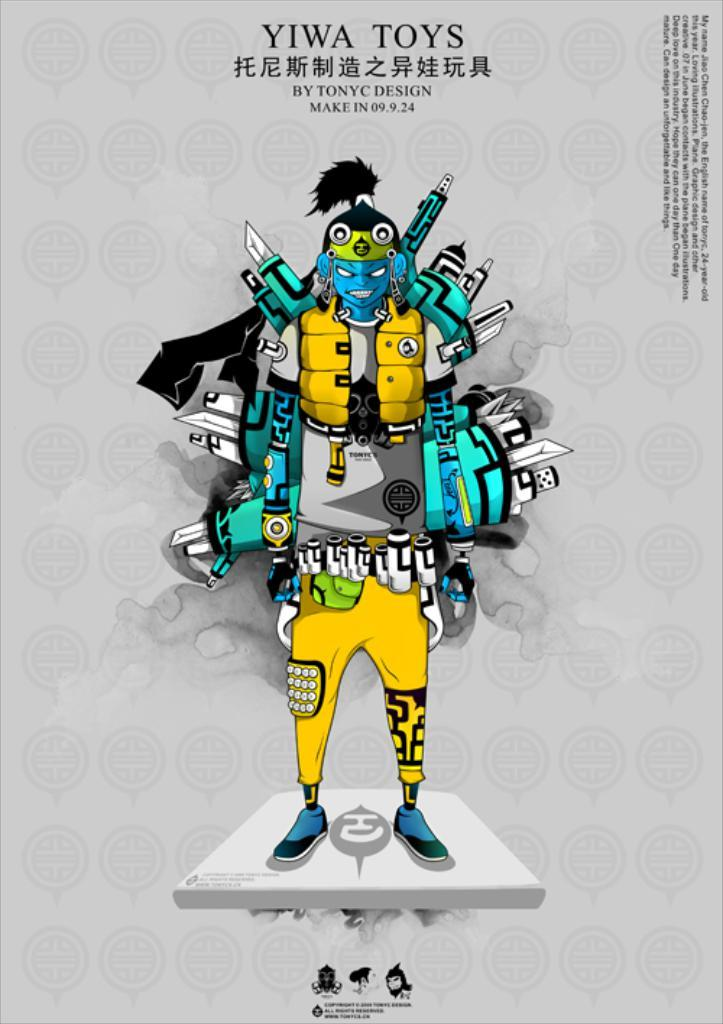What type of image is being described? The image is an animated picture. What shape does the image take? The image is in the shape of a human. What color is the image? The image is yellow in color. How does the image move in rhythm with the flock of birds in the image? There is no mention of a flock of birds in the image or the provided facts, so this question cannot be answered. 